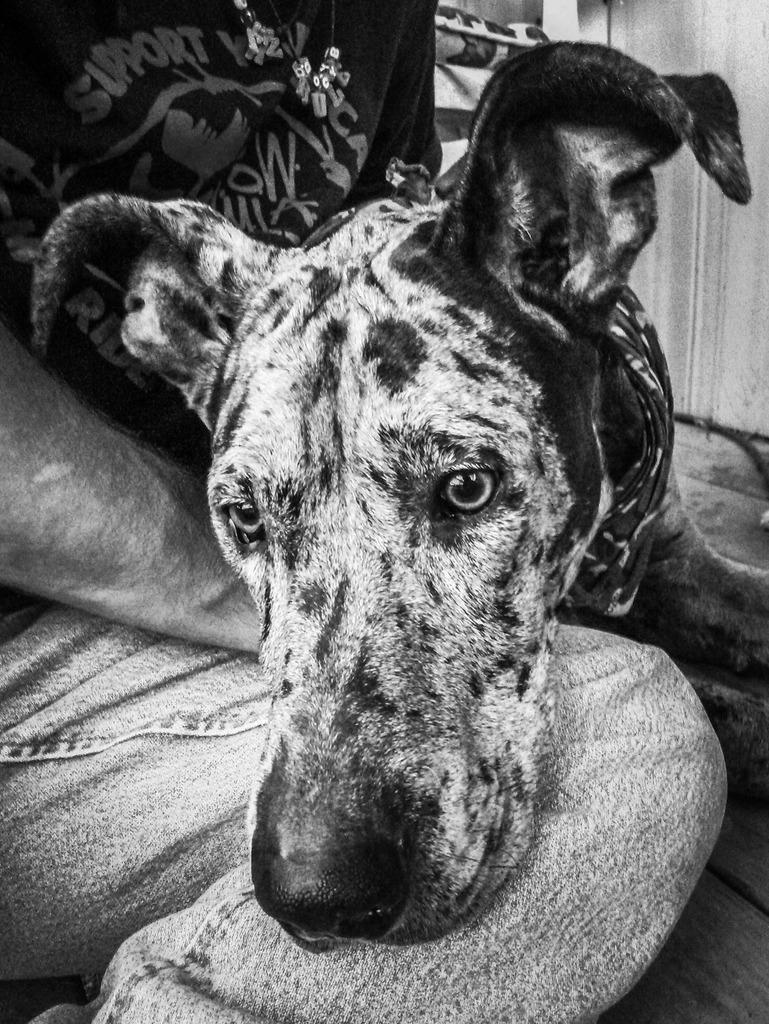What type of animal is in the image? There is a dog in the image. Where is the dog located in relation to a person? The dog is on a person's leg. Can you describe the background of the image? There are objects in the background of the image. How many sisters does the dog have in the image? There are no sisters mentioned or depicted in the image, as it features a dog on a person's leg and objects in the background. 